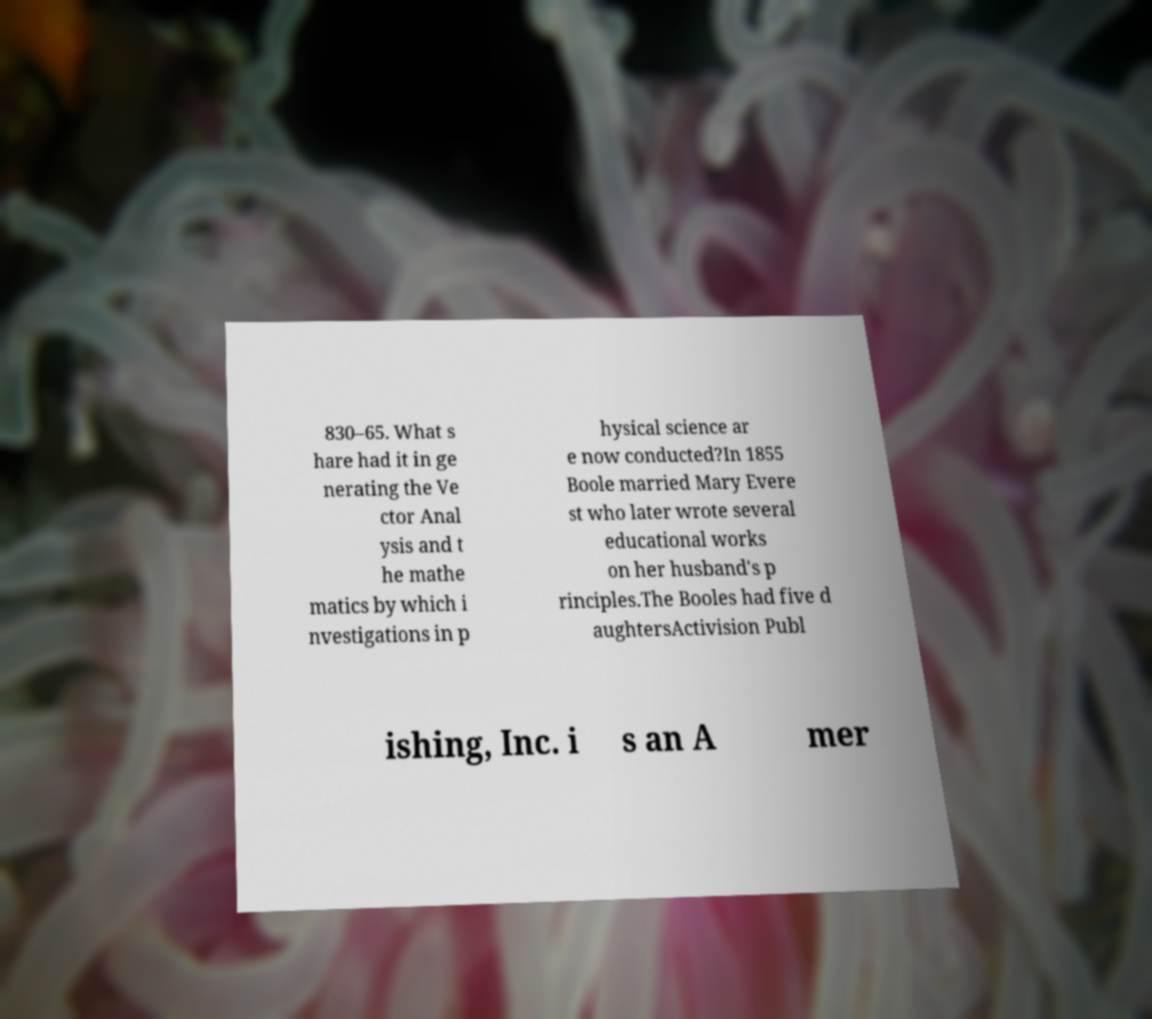I need the written content from this picture converted into text. Can you do that? 830–65. What s hare had it in ge nerating the Ve ctor Anal ysis and t he mathe matics by which i nvestigations in p hysical science ar e now conducted?In 1855 Boole married Mary Evere st who later wrote several educational works on her husband's p rinciples.The Booles had five d aughtersActivision Publ ishing, Inc. i s an A mer 